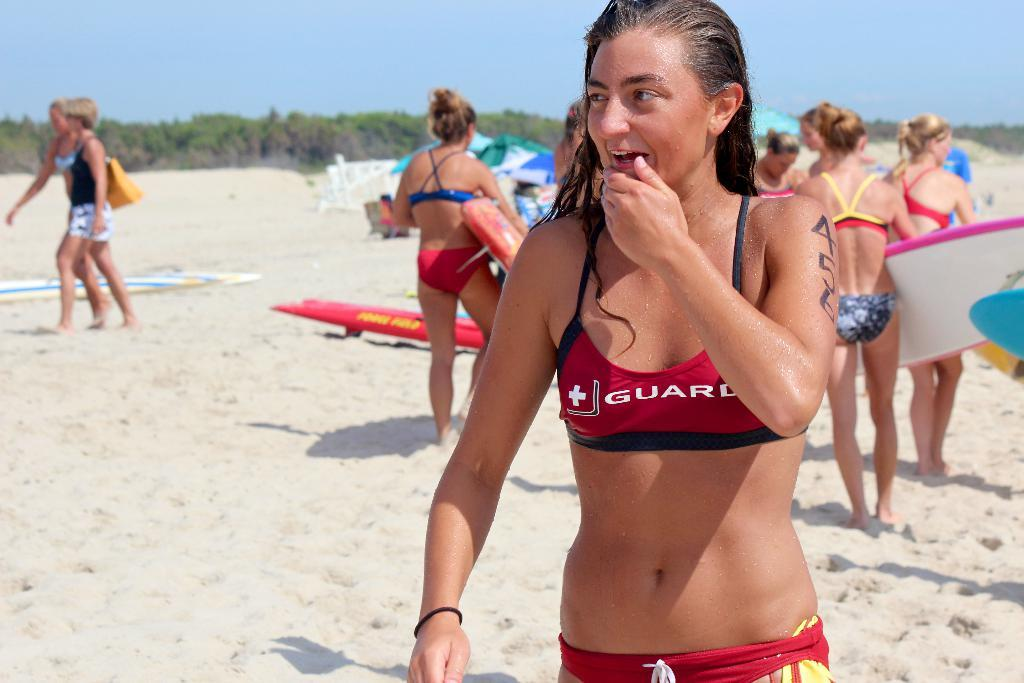<image>
Give a short and clear explanation of the subsequent image. A woman in a bathing suit that says "guard" holds her hand to her mouth. 